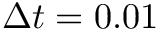Convert formula to latex. <formula><loc_0><loc_0><loc_500><loc_500>\Delta t = 0 . 0 1</formula> 